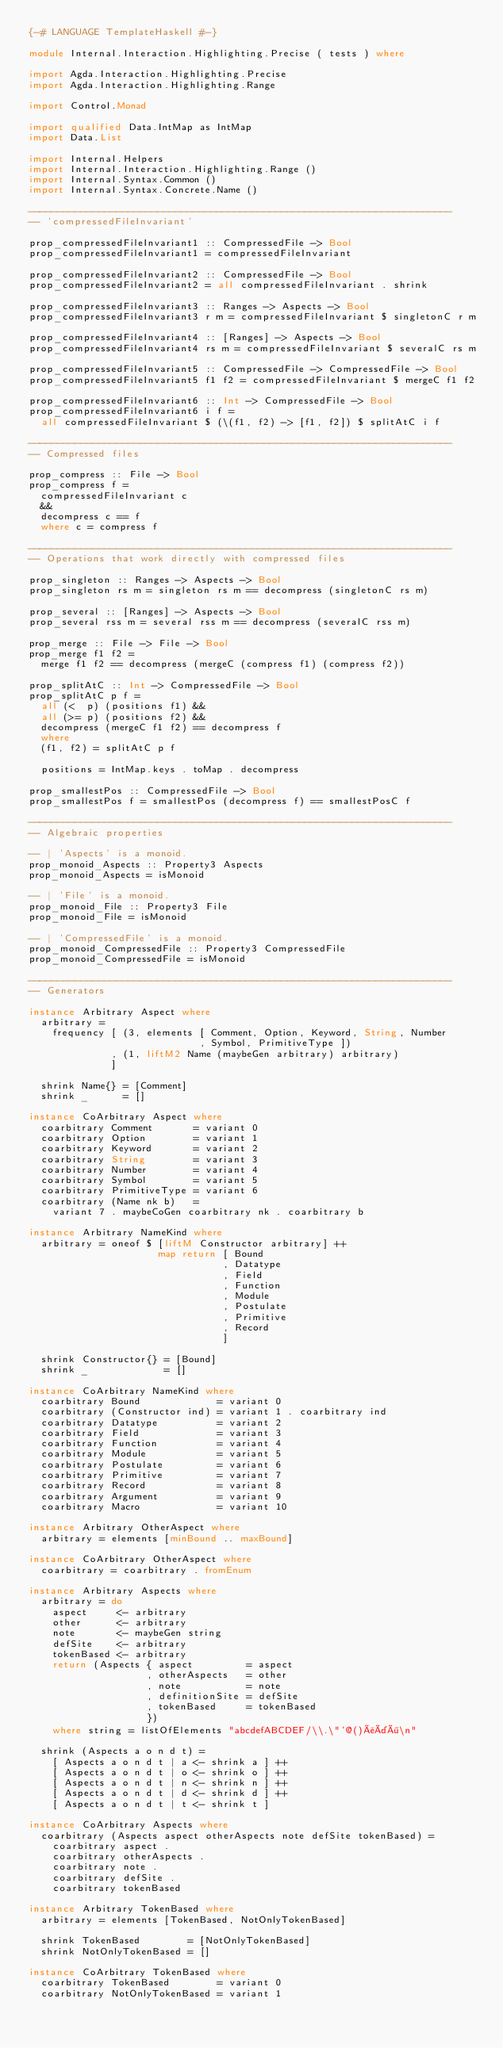Convert code to text. <code><loc_0><loc_0><loc_500><loc_500><_Haskell_>{-# LANGUAGE TemplateHaskell #-}

module Internal.Interaction.Highlighting.Precise ( tests ) where

import Agda.Interaction.Highlighting.Precise
import Agda.Interaction.Highlighting.Range

import Control.Monad

import qualified Data.IntMap as IntMap
import Data.List

import Internal.Helpers
import Internal.Interaction.Highlighting.Range ()
import Internal.Syntax.Common ()
import Internal.Syntax.Concrete.Name ()

------------------------------------------------------------------------
-- 'compressedFileInvariant'

prop_compressedFileInvariant1 :: CompressedFile -> Bool
prop_compressedFileInvariant1 = compressedFileInvariant

prop_compressedFileInvariant2 :: CompressedFile -> Bool
prop_compressedFileInvariant2 = all compressedFileInvariant . shrink

prop_compressedFileInvariant3 :: Ranges -> Aspects -> Bool
prop_compressedFileInvariant3 r m = compressedFileInvariant $ singletonC r m

prop_compressedFileInvariant4 :: [Ranges] -> Aspects -> Bool
prop_compressedFileInvariant4 rs m = compressedFileInvariant $ severalC rs m

prop_compressedFileInvariant5 :: CompressedFile -> CompressedFile -> Bool
prop_compressedFileInvariant5 f1 f2 = compressedFileInvariant $ mergeC f1 f2

prop_compressedFileInvariant6 :: Int -> CompressedFile -> Bool
prop_compressedFileInvariant6 i f =
  all compressedFileInvariant $ (\(f1, f2) -> [f1, f2]) $ splitAtC i f

------------------------------------------------------------------------
-- Compressed files

prop_compress :: File -> Bool
prop_compress f =
  compressedFileInvariant c
  &&
  decompress c == f
  where c = compress f

------------------------------------------------------------------------
-- Operations that work directly with compressed files

prop_singleton :: Ranges -> Aspects -> Bool
prop_singleton rs m = singleton rs m == decompress (singletonC rs m)

prop_several :: [Ranges] -> Aspects -> Bool
prop_several rss m = several rss m == decompress (severalC rss m)

prop_merge :: File -> File -> Bool
prop_merge f1 f2 =
  merge f1 f2 == decompress (mergeC (compress f1) (compress f2))

prop_splitAtC :: Int -> CompressedFile -> Bool
prop_splitAtC p f =
  all (<  p) (positions f1) &&
  all (>= p) (positions f2) &&
  decompress (mergeC f1 f2) == decompress f
  where
  (f1, f2) = splitAtC p f

  positions = IntMap.keys . toMap . decompress

prop_smallestPos :: CompressedFile -> Bool
prop_smallestPos f = smallestPos (decompress f) == smallestPosC f

------------------------------------------------------------------------
-- Algebraic properties

-- | 'Aspects' is a monoid.
prop_monoid_Aspects :: Property3 Aspects
prop_monoid_Aspects = isMonoid

-- | 'File' is a monoid.
prop_monoid_File :: Property3 File
prop_monoid_File = isMonoid

-- | 'CompressedFile' is a monoid.
prop_monoid_CompressedFile :: Property3 CompressedFile
prop_monoid_CompressedFile = isMonoid

------------------------------------------------------------------------
-- Generators

instance Arbitrary Aspect where
  arbitrary =
    frequency [ (3, elements [ Comment, Option, Keyword, String, Number
                             , Symbol, PrimitiveType ])
              , (1, liftM2 Name (maybeGen arbitrary) arbitrary)
              ]

  shrink Name{} = [Comment]
  shrink _      = []

instance CoArbitrary Aspect where
  coarbitrary Comment       = variant 0
  coarbitrary Option        = variant 1
  coarbitrary Keyword       = variant 2
  coarbitrary String        = variant 3
  coarbitrary Number        = variant 4
  coarbitrary Symbol        = variant 5
  coarbitrary PrimitiveType = variant 6
  coarbitrary (Name nk b)   =
    variant 7 . maybeCoGen coarbitrary nk . coarbitrary b

instance Arbitrary NameKind where
  arbitrary = oneof $ [liftM Constructor arbitrary] ++
                      map return [ Bound
                                 , Datatype
                                 , Field
                                 , Function
                                 , Module
                                 , Postulate
                                 , Primitive
                                 , Record
                                 ]

  shrink Constructor{} = [Bound]
  shrink _             = []

instance CoArbitrary NameKind where
  coarbitrary Bound             = variant 0
  coarbitrary (Constructor ind) = variant 1 . coarbitrary ind
  coarbitrary Datatype          = variant 2
  coarbitrary Field             = variant 3
  coarbitrary Function          = variant 4
  coarbitrary Module            = variant 5
  coarbitrary Postulate         = variant 6
  coarbitrary Primitive         = variant 7
  coarbitrary Record            = variant 8
  coarbitrary Argument          = variant 9
  coarbitrary Macro             = variant 10

instance Arbitrary OtherAspect where
  arbitrary = elements [minBound .. maxBound]

instance CoArbitrary OtherAspect where
  coarbitrary = coarbitrary . fromEnum

instance Arbitrary Aspects where
  arbitrary = do
    aspect     <- arbitrary
    other      <- arbitrary
    note       <- maybeGen string
    defSite    <- arbitrary
    tokenBased <- arbitrary
    return (Aspects { aspect         = aspect
                    , otherAspects   = other
                    , note           = note
                    , definitionSite = defSite
                    , tokenBased     = tokenBased
                    })
    where string = listOfElements "abcdefABCDEF/\\.\"'@()åäö\n"

  shrink (Aspects a o n d t) =
    [ Aspects a o n d t | a <- shrink a ] ++
    [ Aspects a o n d t | o <- shrink o ] ++
    [ Aspects a o n d t | n <- shrink n ] ++
    [ Aspects a o n d t | d <- shrink d ] ++
    [ Aspects a o n d t | t <- shrink t ]

instance CoArbitrary Aspects where
  coarbitrary (Aspects aspect otherAspects note defSite tokenBased) =
    coarbitrary aspect .
    coarbitrary otherAspects .
    coarbitrary note .
    coarbitrary defSite .
    coarbitrary tokenBased

instance Arbitrary TokenBased where
  arbitrary = elements [TokenBased, NotOnlyTokenBased]

  shrink TokenBased        = [NotOnlyTokenBased]
  shrink NotOnlyTokenBased = []

instance CoArbitrary TokenBased where
  coarbitrary TokenBased        = variant 0
  coarbitrary NotOnlyTokenBased = variant 1
</code> 